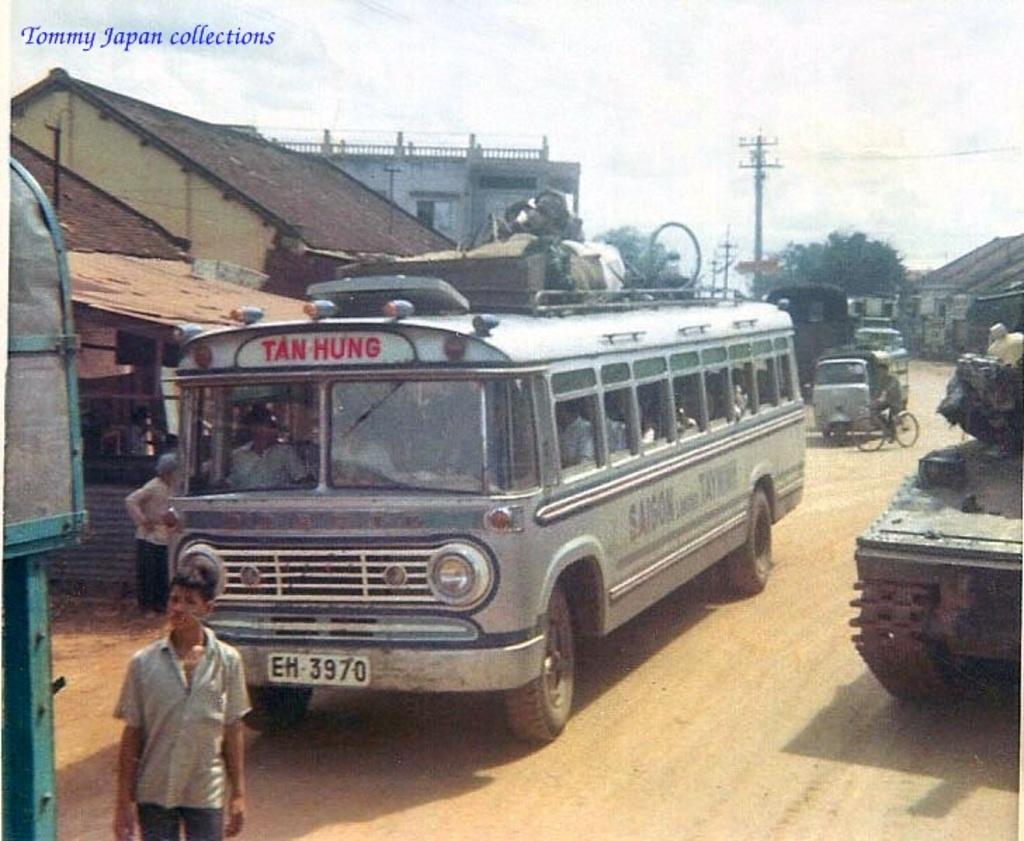<image>
Describe the image concisely. A Tan Hung bus with licensed plate EH 3970 at a bus stop 